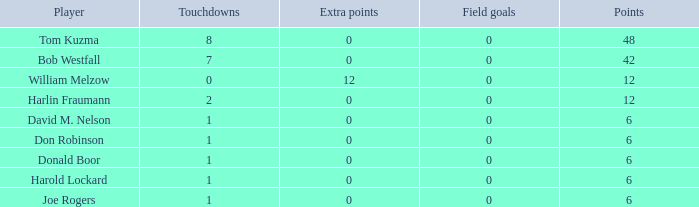Identify the points associated with donald boor. 6.0. 